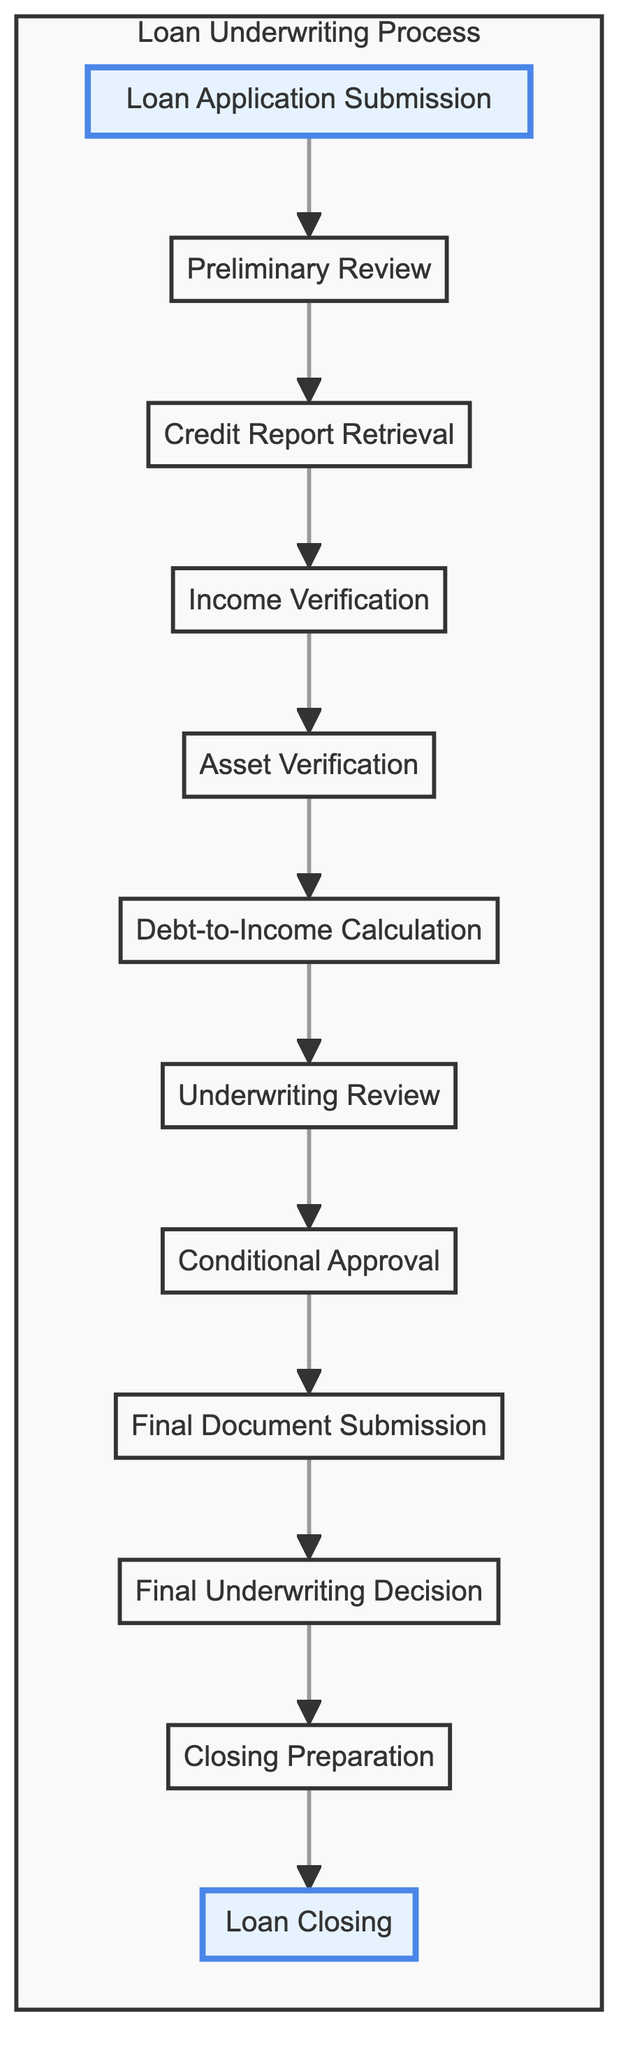What is the first step in the loan underwriting process? The first step in the loan underwriting process, as indicated in the diagram, is "Loan Application Submission".
Answer: Loan Application Submission How many total steps are there in the underwriting process? By counting the nodes in the diagram, there are 12 steps from "Loan Application Submission" to "Loan Closing".
Answer: 12 Which step comes immediately after "Conditional Approval"? The step that comes immediately after "Conditional Approval" is "Final Document Submission".
Answer: Final Document Submission What is required during "Income Verification"? During "Income Verification," the required actions include collecting and verifying the borrower's income through documents like pay stubs, tax returns, and employment letters.
Answer: Collecting and verifying borrower's income What color represents the "Final Underwriting Decision"? The "Final Underwriting Decision" is represented in the diagram with a color corresponding to "f8d7da" which signifies a red tone, indicating a critical step.
Answer: Red How is "Debt-to-Income Calculation" connected to "Income Verification"? "Debt-to-Income Calculation" is directly connected to "Income Verification" as the subsequent step that evaluates the borrower's financial standing based on verified income data.
Answer: Directly connected What happens in the "Underwriting Review"? In the "Underwriting Review," the complete application is submitted to an underwriter for a thorough evaluation of risk factors associated with the loan.
Answer: Evaluation of risk factors What step is visually highlighted at the bottom of the diagram? The visually highlighted step at the bottom of the diagram is "Loan Closing," signifying the finalization of the loan agreement with the borrower.
Answer: Loan Closing What documentation does a borrower need to submit after "Conditional Approval"? After receiving "Conditional Approval," the borrower needs to submit additional documents required to satisfy underwriting conditions.
Answer: Additional documents required 